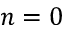Convert formula to latex. <formula><loc_0><loc_0><loc_500><loc_500>n = 0</formula> 